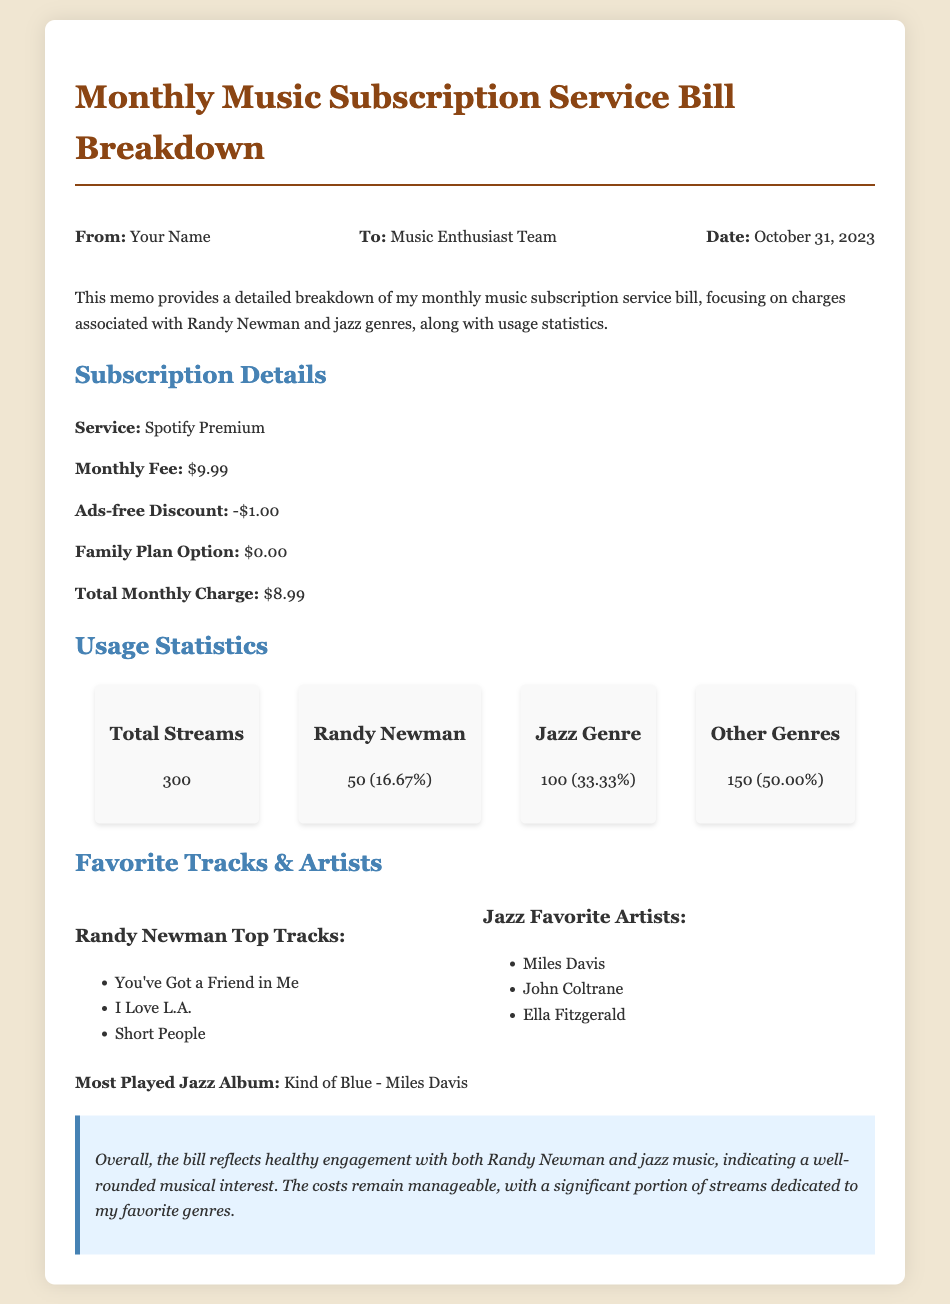What is the monthly fee for the subscription? The monthly fee is listed in the subscription details section of the document, which states it is $9.99.
Answer: $9.99 How much is the ads-free discount? The ads-free discount is mentioned as a deduction in the subscription details, which is -$1.00.
Answer: -$1.00 What percentage of total streams is associated with Randy Newman? The usage statistics provide the percentage for Randy Newman as 16.67% of total streams.
Answer: 16.67% How many jazz genre streams were recorded? In the usage statistics section, the document indicates there were 100 streams dedicated to the jazz genre.
Answer: 100 What is the most played jazz album? The document lists the most played jazz album as "Kind of Blue - Miles Davis" in the favorite tracks and artists section.
Answer: Kind of Blue - Miles Davis What is the total number of streams recorded? The total number of streams is explicitly provided in the usage statistics section, which states there are 300 streams.
Answer: 300 What reflects a well-rounded musical interest according to the conclusion? The conclusion discusses healthy engagement with both Randy Newman and jazz music as indicative of a well-rounded musical interest.
Answer: Healthy engagement What service is mentioned in the subscription details? The subscription details section specifies "Spotify Premium" as the service being used.
Answer: Spotify Premium Which artist has the most tracks listed under favorite tracks? The favorite tracks section includes multiple tracks by Randy Newman, indicating he has the most tracks listed.
Answer: Randy Newman 